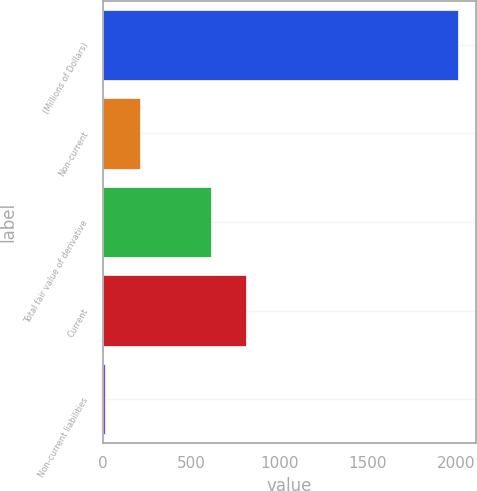<chart> <loc_0><loc_0><loc_500><loc_500><bar_chart><fcel>(Millions of Dollars)<fcel>Non-current<fcel>Total fair value of derivative<fcel>Current<fcel>Non-current liabilities<nl><fcel>2014<fcel>210.4<fcel>611.2<fcel>811.6<fcel>10<nl></chart> 